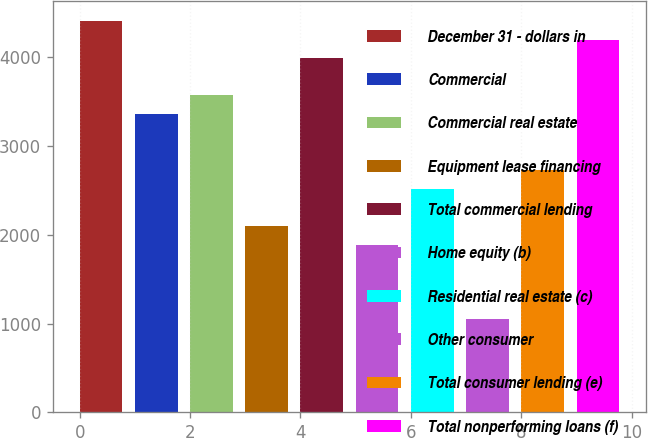<chart> <loc_0><loc_0><loc_500><loc_500><bar_chart><fcel>December 31 - dollars in<fcel>Commercial<fcel>Commercial real estate<fcel>Equipment lease financing<fcel>Total commercial lending<fcel>Home equity (b)<fcel>Residential real estate (c)<fcel>Other consumer<fcel>Total consumer lending (e)<fcel>Total nonperforming loans (f)<nl><fcel>4409.25<fcel>3359.6<fcel>3569.53<fcel>2100.02<fcel>3989.39<fcel>1890.09<fcel>2519.88<fcel>1050.37<fcel>2729.81<fcel>4199.32<nl></chart> 